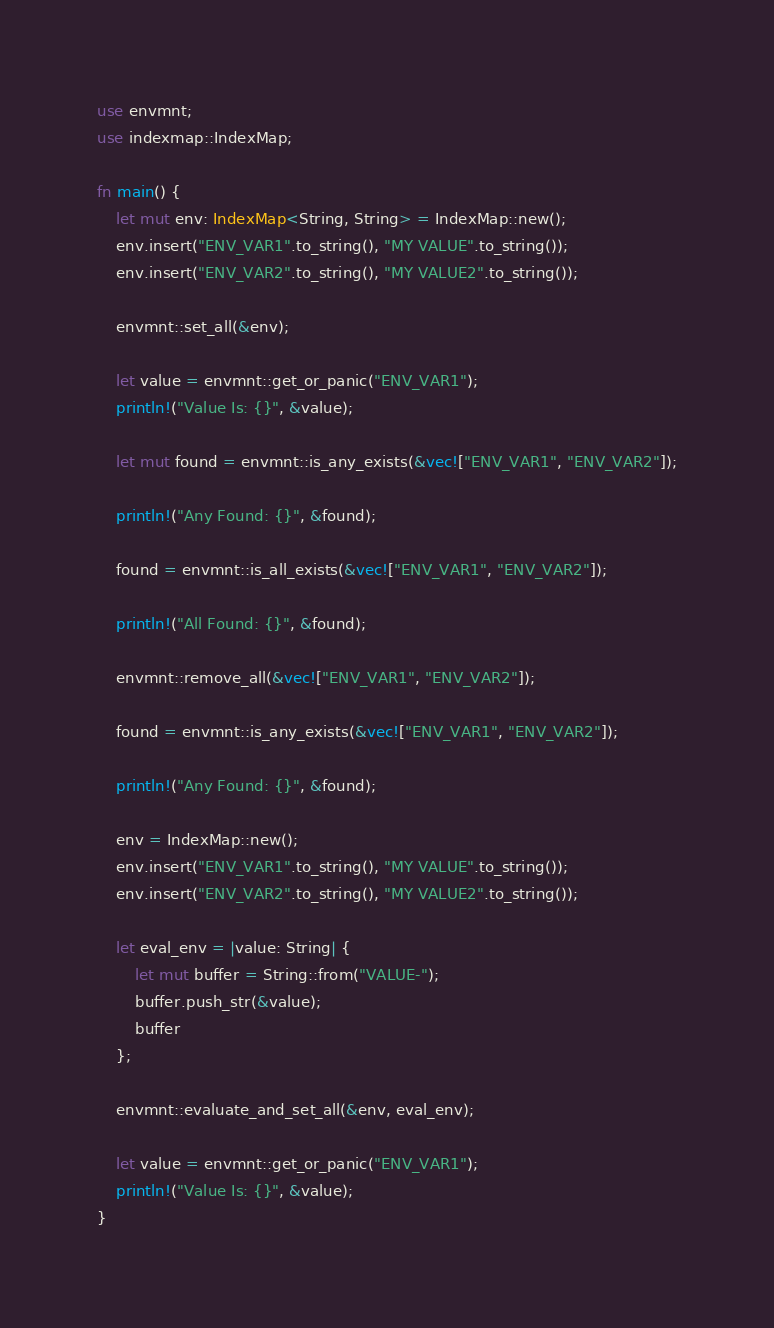<code> <loc_0><loc_0><loc_500><loc_500><_Rust_>use envmnt;
use indexmap::IndexMap;

fn main() {
    let mut env: IndexMap<String, String> = IndexMap::new();
    env.insert("ENV_VAR1".to_string(), "MY VALUE".to_string());
    env.insert("ENV_VAR2".to_string(), "MY VALUE2".to_string());

    envmnt::set_all(&env);

    let value = envmnt::get_or_panic("ENV_VAR1");
    println!("Value Is: {}", &value);

    let mut found = envmnt::is_any_exists(&vec!["ENV_VAR1", "ENV_VAR2"]);

    println!("Any Found: {}", &found);

    found = envmnt::is_all_exists(&vec!["ENV_VAR1", "ENV_VAR2"]);

    println!("All Found: {}", &found);

    envmnt::remove_all(&vec!["ENV_VAR1", "ENV_VAR2"]);

    found = envmnt::is_any_exists(&vec!["ENV_VAR1", "ENV_VAR2"]);

    println!("Any Found: {}", &found);

    env = IndexMap::new();
    env.insert("ENV_VAR1".to_string(), "MY VALUE".to_string());
    env.insert("ENV_VAR2".to_string(), "MY VALUE2".to_string());

    let eval_env = |value: String| {
        let mut buffer = String::from("VALUE-");
        buffer.push_str(&value);
        buffer
    };

    envmnt::evaluate_and_set_all(&env, eval_env);

    let value = envmnt::get_or_panic("ENV_VAR1");
    println!("Value Is: {}", &value);
}
</code> 